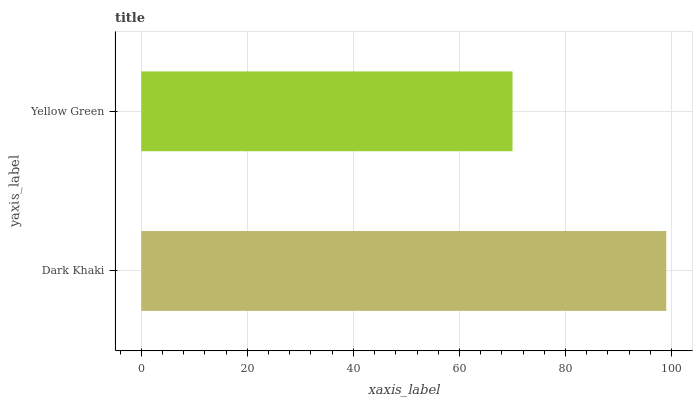Is Yellow Green the minimum?
Answer yes or no. Yes. Is Dark Khaki the maximum?
Answer yes or no. Yes. Is Yellow Green the maximum?
Answer yes or no. No. Is Dark Khaki greater than Yellow Green?
Answer yes or no. Yes. Is Yellow Green less than Dark Khaki?
Answer yes or no. Yes. Is Yellow Green greater than Dark Khaki?
Answer yes or no. No. Is Dark Khaki less than Yellow Green?
Answer yes or no. No. Is Dark Khaki the high median?
Answer yes or no. Yes. Is Yellow Green the low median?
Answer yes or no. Yes. Is Yellow Green the high median?
Answer yes or no. No. Is Dark Khaki the low median?
Answer yes or no. No. 